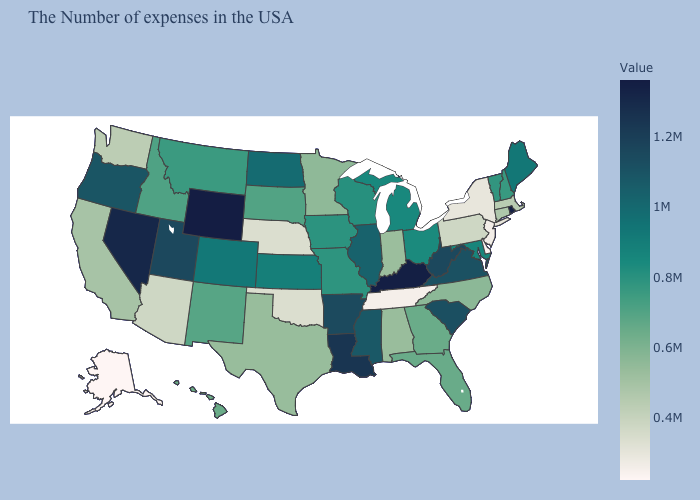Does Illinois have the highest value in the MidWest?
Keep it brief. Yes. Among the states that border Connecticut , does Rhode Island have the lowest value?
Be succinct. No. Which states hav the highest value in the Northeast?
Answer briefly. Rhode Island. Among the states that border Missouri , which have the lowest value?
Quick response, please. Tennessee. Does Wisconsin have a higher value than Colorado?
Quick response, please. No. 